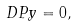<formula> <loc_0><loc_0><loc_500><loc_500>\ D { P } { y } = 0 ,</formula> 